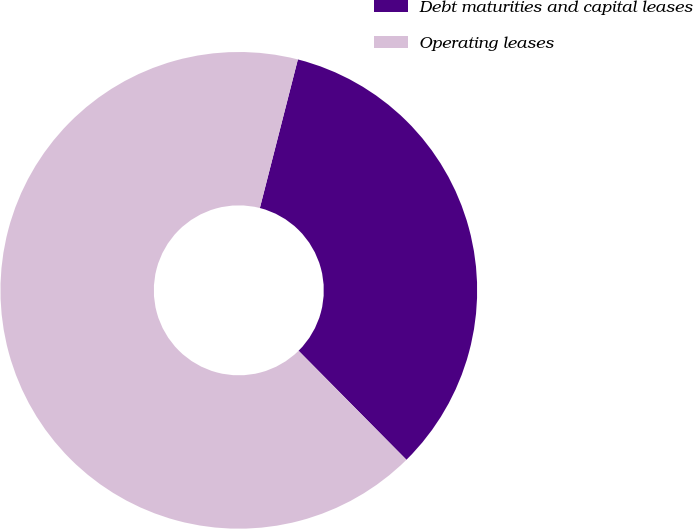Convert chart to OTSL. <chart><loc_0><loc_0><loc_500><loc_500><pie_chart><fcel>Debt maturities and capital leases<fcel>Operating leases<nl><fcel>33.6%<fcel>66.4%<nl></chart> 